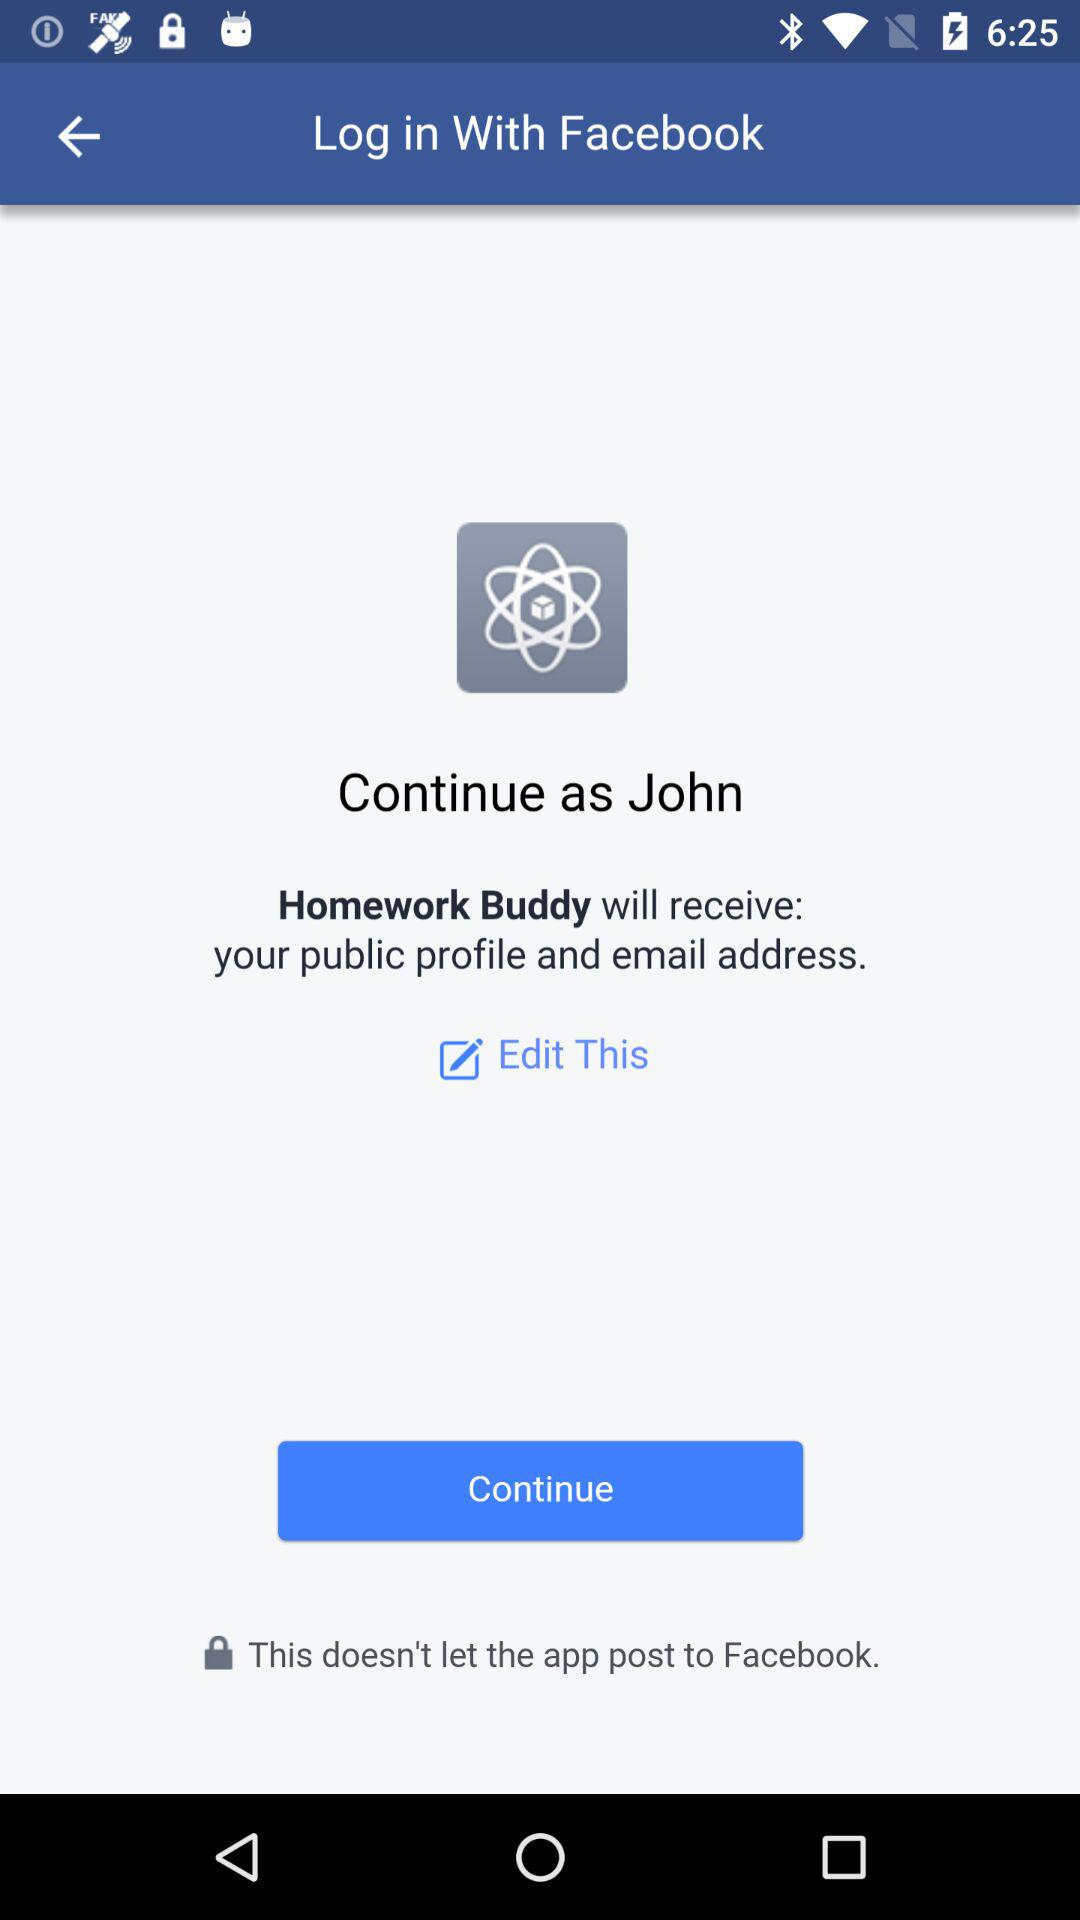What is the application name? The application name is "Facebook". 